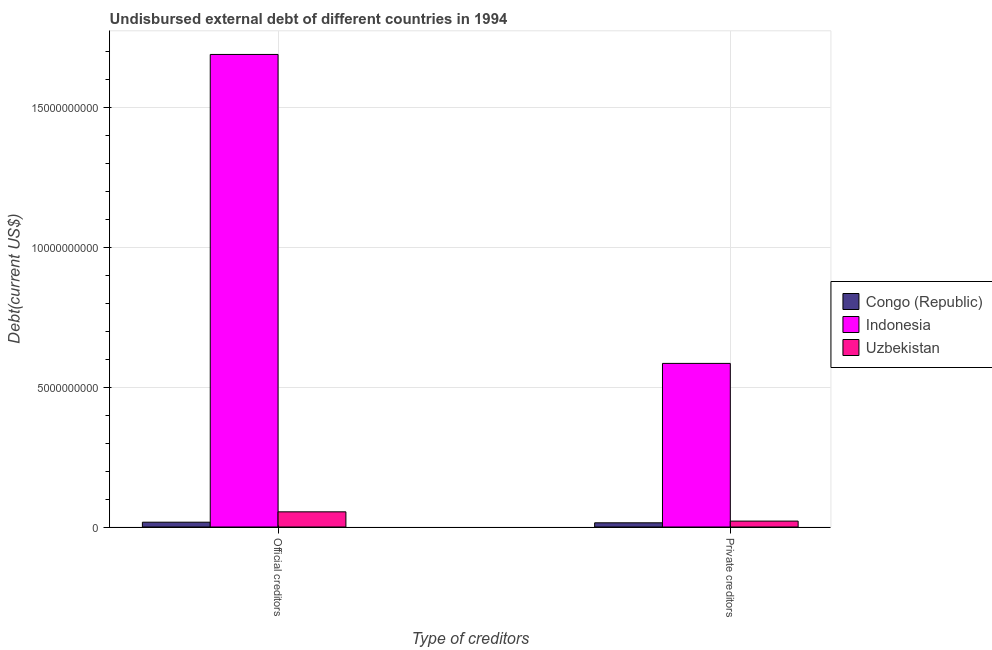How many different coloured bars are there?
Offer a very short reply. 3. How many groups of bars are there?
Your response must be concise. 2. How many bars are there on the 2nd tick from the left?
Give a very brief answer. 3. What is the label of the 1st group of bars from the left?
Offer a very short reply. Official creditors. What is the undisbursed external debt of official creditors in Congo (Republic)?
Provide a short and direct response. 1.72e+08. Across all countries, what is the maximum undisbursed external debt of private creditors?
Give a very brief answer. 5.85e+09. Across all countries, what is the minimum undisbursed external debt of private creditors?
Your response must be concise. 1.50e+08. In which country was the undisbursed external debt of private creditors minimum?
Give a very brief answer. Congo (Republic). What is the total undisbursed external debt of private creditors in the graph?
Provide a short and direct response. 6.21e+09. What is the difference between the undisbursed external debt of official creditors in Uzbekistan and that in Congo (Republic)?
Make the answer very short. 3.71e+08. What is the difference between the undisbursed external debt of private creditors in Congo (Republic) and the undisbursed external debt of official creditors in Indonesia?
Your answer should be very brief. -1.68e+1. What is the average undisbursed external debt of official creditors per country?
Your answer should be compact. 5.87e+09. What is the difference between the undisbursed external debt of official creditors and undisbursed external debt of private creditors in Indonesia?
Your answer should be very brief. 1.10e+1. In how many countries, is the undisbursed external debt of private creditors greater than 9000000000 US$?
Provide a short and direct response. 0. What is the ratio of the undisbursed external debt of official creditors in Indonesia to that in Uzbekistan?
Offer a very short reply. 31.14. Is the undisbursed external debt of official creditors in Uzbekistan less than that in Congo (Republic)?
Your answer should be compact. No. What does the 2nd bar from the left in Official creditors represents?
Keep it short and to the point. Indonesia. How many countries are there in the graph?
Provide a succinct answer. 3. Are the values on the major ticks of Y-axis written in scientific E-notation?
Your answer should be compact. No. How many legend labels are there?
Keep it short and to the point. 3. How are the legend labels stacked?
Offer a terse response. Vertical. What is the title of the graph?
Ensure brevity in your answer.  Undisbursed external debt of different countries in 1994. Does "Belarus" appear as one of the legend labels in the graph?
Your answer should be compact. No. What is the label or title of the X-axis?
Provide a short and direct response. Type of creditors. What is the label or title of the Y-axis?
Make the answer very short. Debt(current US$). What is the Debt(current US$) in Congo (Republic) in Official creditors?
Your answer should be very brief. 1.72e+08. What is the Debt(current US$) in Indonesia in Official creditors?
Give a very brief answer. 1.69e+1. What is the Debt(current US$) in Uzbekistan in Official creditors?
Your answer should be compact. 5.43e+08. What is the Debt(current US$) in Congo (Republic) in Private creditors?
Offer a terse response. 1.50e+08. What is the Debt(current US$) in Indonesia in Private creditors?
Give a very brief answer. 5.85e+09. What is the Debt(current US$) of Uzbekistan in Private creditors?
Offer a very short reply. 2.12e+08. Across all Type of creditors, what is the maximum Debt(current US$) in Congo (Republic)?
Ensure brevity in your answer.  1.72e+08. Across all Type of creditors, what is the maximum Debt(current US$) of Indonesia?
Give a very brief answer. 1.69e+1. Across all Type of creditors, what is the maximum Debt(current US$) in Uzbekistan?
Your answer should be very brief. 5.43e+08. Across all Type of creditors, what is the minimum Debt(current US$) in Congo (Republic)?
Provide a short and direct response. 1.50e+08. Across all Type of creditors, what is the minimum Debt(current US$) in Indonesia?
Your answer should be very brief. 5.85e+09. Across all Type of creditors, what is the minimum Debt(current US$) of Uzbekistan?
Give a very brief answer. 2.12e+08. What is the total Debt(current US$) of Congo (Republic) in the graph?
Your answer should be very brief. 3.23e+08. What is the total Debt(current US$) of Indonesia in the graph?
Provide a short and direct response. 2.28e+1. What is the total Debt(current US$) in Uzbekistan in the graph?
Your answer should be compact. 7.54e+08. What is the difference between the Debt(current US$) of Congo (Republic) in Official creditors and that in Private creditors?
Your answer should be compact. 2.16e+07. What is the difference between the Debt(current US$) of Indonesia in Official creditors and that in Private creditors?
Provide a succinct answer. 1.10e+1. What is the difference between the Debt(current US$) in Uzbekistan in Official creditors and that in Private creditors?
Offer a very short reply. 3.31e+08. What is the difference between the Debt(current US$) of Congo (Republic) in Official creditors and the Debt(current US$) of Indonesia in Private creditors?
Offer a terse response. -5.68e+09. What is the difference between the Debt(current US$) of Congo (Republic) in Official creditors and the Debt(current US$) of Uzbekistan in Private creditors?
Offer a terse response. -3.95e+07. What is the difference between the Debt(current US$) in Indonesia in Official creditors and the Debt(current US$) in Uzbekistan in Private creditors?
Keep it short and to the point. 1.67e+1. What is the average Debt(current US$) of Congo (Republic) per Type of creditors?
Your answer should be compact. 1.61e+08. What is the average Debt(current US$) of Indonesia per Type of creditors?
Provide a succinct answer. 1.14e+1. What is the average Debt(current US$) of Uzbekistan per Type of creditors?
Your response must be concise. 3.77e+08. What is the difference between the Debt(current US$) in Congo (Republic) and Debt(current US$) in Indonesia in Official creditors?
Give a very brief answer. -1.67e+1. What is the difference between the Debt(current US$) of Congo (Republic) and Debt(current US$) of Uzbekistan in Official creditors?
Give a very brief answer. -3.71e+08. What is the difference between the Debt(current US$) in Indonesia and Debt(current US$) in Uzbekistan in Official creditors?
Ensure brevity in your answer.  1.64e+1. What is the difference between the Debt(current US$) in Congo (Republic) and Debt(current US$) in Indonesia in Private creditors?
Provide a succinct answer. -5.70e+09. What is the difference between the Debt(current US$) of Congo (Republic) and Debt(current US$) of Uzbekistan in Private creditors?
Provide a short and direct response. -6.11e+07. What is the difference between the Debt(current US$) of Indonesia and Debt(current US$) of Uzbekistan in Private creditors?
Offer a very short reply. 5.64e+09. What is the ratio of the Debt(current US$) in Congo (Republic) in Official creditors to that in Private creditors?
Provide a succinct answer. 1.14. What is the ratio of the Debt(current US$) in Indonesia in Official creditors to that in Private creditors?
Your answer should be compact. 2.89. What is the ratio of the Debt(current US$) of Uzbekistan in Official creditors to that in Private creditors?
Your response must be concise. 2.57. What is the difference between the highest and the second highest Debt(current US$) of Congo (Republic)?
Provide a succinct answer. 2.16e+07. What is the difference between the highest and the second highest Debt(current US$) of Indonesia?
Make the answer very short. 1.10e+1. What is the difference between the highest and the second highest Debt(current US$) in Uzbekistan?
Make the answer very short. 3.31e+08. What is the difference between the highest and the lowest Debt(current US$) in Congo (Republic)?
Provide a succinct answer. 2.16e+07. What is the difference between the highest and the lowest Debt(current US$) in Indonesia?
Keep it short and to the point. 1.10e+1. What is the difference between the highest and the lowest Debt(current US$) of Uzbekistan?
Provide a succinct answer. 3.31e+08. 